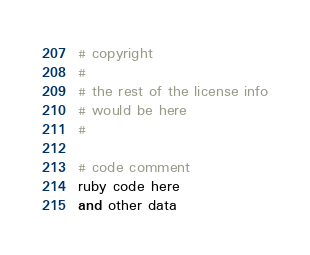<code> <loc_0><loc_0><loc_500><loc_500><_Ruby_># copyright
# 
# the rest of the license info
# would be here
# 

# code comment
ruby code here
and other data
</code> 